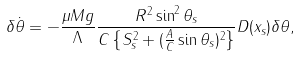Convert formula to latex. <formula><loc_0><loc_0><loc_500><loc_500>\delta { \dot { \theta } } = - \frac { \mu M g } { \Lambda } \frac { R ^ { 2 } \sin ^ { 2 } \theta _ { s } } { C \left \{ S ^ { 2 } _ { s } + ( \frac { A } { C } \sin \theta _ { s } ) ^ { 2 } \right \} } D ( x _ { s } ) \delta \theta ,</formula> 